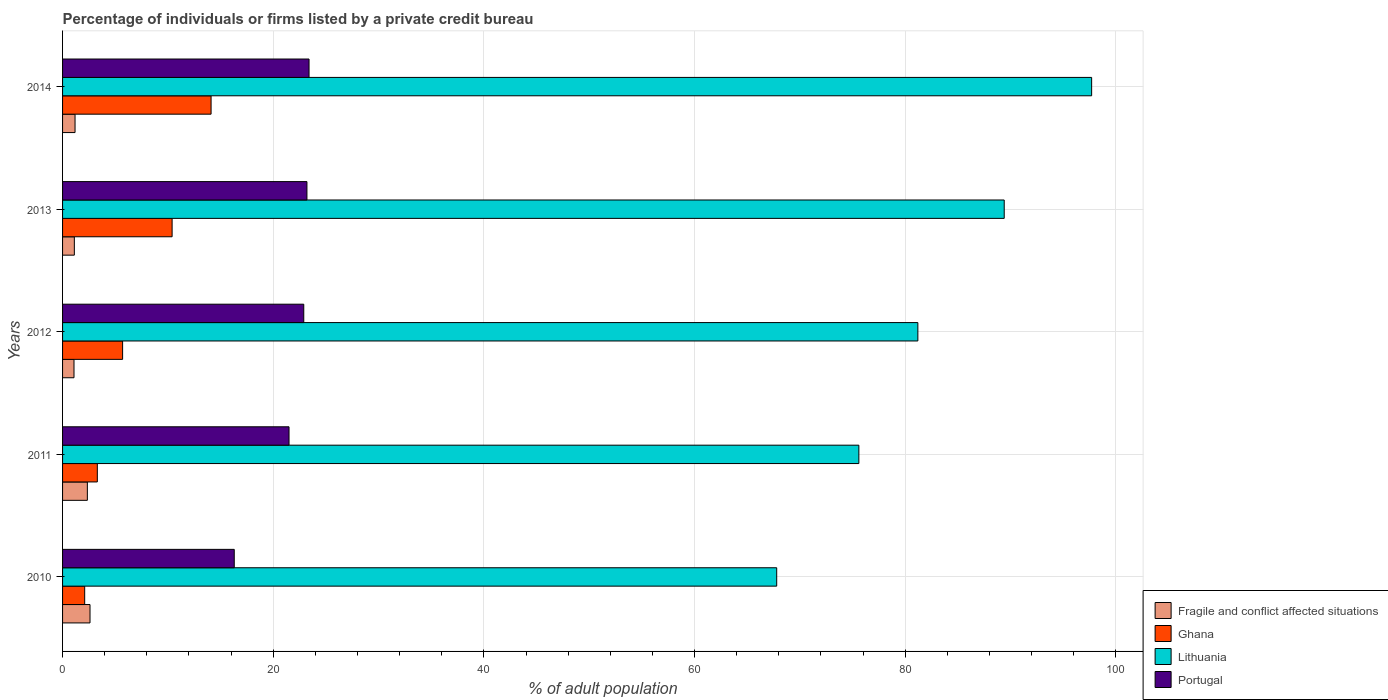How many different coloured bars are there?
Ensure brevity in your answer.  4. Are the number of bars on each tick of the Y-axis equal?
Offer a terse response. Yes. In how many cases, is the number of bars for a given year not equal to the number of legend labels?
Give a very brief answer. 0. What is the percentage of population listed by a private credit bureau in Portugal in 2013?
Make the answer very short. 23.2. Across all years, what is the maximum percentage of population listed by a private credit bureau in Fragile and conflict affected situations?
Offer a terse response. 2.61. Across all years, what is the minimum percentage of population listed by a private credit bureau in Portugal?
Your answer should be very brief. 16.3. What is the total percentage of population listed by a private credit bureau in Portugal in the graph?
Provide a short and direct response. 107.3. What is the difference between the percentage of population listed by a private credit bureau in Lithuania in 2012 and that in 2013?
Provide a short and direct response. -8.2. What is the difference between the percentage of population listed by a private credit bureau in Ghana in 2010 and the percentage of population listed by a private credit bureau in Portugal in 2011?
Your response must be concise. -19.4. What is the average percentage of population listed by a private credit bureau in Lithuania per year?
Your response must be concise. 82.34. In the year 2013, what is the difference between the percentage of population listed by a private credit bureau in Ghana and percentage of population listed by a private credit bureau in Fragile and conflict affected situations?
Provide a succinct answer. 9.28. In how many years, is the percentage of population listed by a private credit bureau in Lithuania greater than 24 %?
Offer a terse response. 5. What is the ratio of the percentage of population listed by a private credit bureau in Lithuania in 2011 to that in 2012?
Make the answer very short. 0.93. Is the percentage of population listed by a private credit bureau in Lithuania in 2013 less than that in 2014?
Provide a succinct answer. Yes. Is the difference between the percentage of population listed by a private credit bureau in Ghana in 2011 and 2014 greater than the difference between the percentage of population listed by a private credit bureau in Fragile and conflict affected situations in 2011 and 2014?
Provide a short and direct response. No. What is the difference between the highest and the second highest percentage of population listed by a private credit bureau in Portugal?
Offer a very short reply. 0.2. In how many years, is the percentage of population listed by a private credit bureau in Lithuania greater than the average percentage of population listed by a private credit bureau in Lithuania taken over all years?
Offer a terse response. 2. Is the sum of the percentage of population listed by a private credit bureau in Portugal in 2010 and 2013 greater than the maximum percentage of population listed by a private credit bureau in Ghana across all years?
Offer a terse response. Yes. Is it the case that in every year, the sum of the percentage of population listed by a private credit bureau in Ghana and percentage of population listed by a private credit bureau in Fragile and conflict affected situations is greater than the sum of percentage of population listed by a private credit bureau in Lithuania and percentage of population listed by a private credit bureau in Portugal?
Offer a very short reply. Yes. What does the 2nd bar from the top in 2011 represents?
Provide a short and direct response. Lithuania. What does the 4th bar from the bottom in 2014 represents?
Your response must be concise. Portugal. Is it the case that in every year, the sum of the percentage of population listed by a private credit bureau in Ghana and percentage of population listed by a private credit bureau in Lithuania is greater than the percentage of population listed by a private credit bureau in Fragile and conflict affected situations?
Provide a short and direct response. Yes. How many bars are there?
Make the answer very short. 20. Are all the bars in the graph horizontal?
Your response must be concise. Yes. Does the graph contain any zero values?
Ensure brevity in your answer.  No. Does the graph contain grids?
Offer a terse response. Yes. What is the title of the graph?
Your answer should be compact. Percentage of individuals or firms listed by a private credit bureau. What is the label or title of the X-axis?
Make the answer very short. % of adult population. What is the label or title of the Y-axis?
Keep it short and to the point. Years. What is the % of adult population in Fragile and conflict affected situations in 2010?
Ensure brevity in your answer.  2.61. What is the % of adult population in Ghana in 2010?
Offer a very short reply. 2.1. What is the % of adult population in Lithuania in 2010?
Provide a short and direct response. 67.8. What is the % of adult population of Portugal in 2010?
Your answer should be very brief. 16.3. What is the % of adult population in Fragile and conflict affected situations in 2011?
Offer a terse response. 2.35. What is the % of adult population of Lithuania in 2011?
Provide a short and direct response. 75.6. What is the % of adult population of Portugal in 2011?
Make the answer very short. 21.5. What is the % of adult population of Fragile and conflict affected situations in 2012?
Make the answer very short. 1.08. What is the % of adult population of Lithuania in 2012?
Your response must be concise. 81.2. What is the % of adult population in Portugal in 2012?
Make the answer very short. 22.9. What is the % of adult population in Fragile and conflict affected situations in 2013?
Offer a very short reply. 1.12. What is the % of adult population of Lithuania in 2013?
Offer a very short reply. 89.4. What is the % of adult population in Portugal in 2013?
Ensure brevity in your answer.  23.2. What is the % of adult population of Fragile and conflict affected situations in 2014?
Keep it short and to the point. 1.18. What is the % of adult population in Lithuania in 2014?
Keep it short and to the point. 97.7. What is the % of adult population of Portugal in 2014?
Ensure brevity in your answer.  23.4. Across all years, what is the maximum % of adult population in Fragile and conflict affected situations?
Provide a succinct answer. 2.61. Across all years, what is the maximum % of adult population in Lithuania?
Ensure brevity in your answer.  97.7. Across all years, what is the maximum % of adult population in Portugal?
Provide a succinct answer. 23.4. Across all years, what is the minimum % of adult population in Fragile and conflict affected situations?
Make the answer very short. 1.08. Across all years, what is the minimum % of adult population of Lithuania?
Offer a very short reply. 67.8. What is the total % of adult population in Fragile and conflict affected situations in the graph?
Your answer should be very brief. 8.35. What is the total % of adult population of Ghana in the graph?
Offer a very short reply. 35.6. What is the total % of adult population of Lithuania in the graph?
Offer a terse response. 411.7. What is the total % of adult population of Portugal in the graph?
Give a very brief answer. 107.3. What is the difference between the % of adult population of Fragile and conflict affected situations in 2010 and that in 2011?
Offer a terse response. 0.25. What is the difference between the % of adult population in Ghana in 2010 and that in 2011?
Offer a very short reply. -1.2. What is the difference between the % of adult population in Lithuania in 2010 and that in 2011?
Your answer should be compact. -7.8. What is the difference between the % of adult population in Fragile and conflict affected situations in 2010 and that in 2012?
Your answer should be compact. 1.52. What is the difference between the % of adult population in Lithuania in 2010 and that in 2012?
Give a very brief answer. -13.4. What is the difference between the % of adult population of Portugal in 2010 and that in 2012?
Give a very brief answer. -6.6. What is the difference between the % of adult population in Fragile and conflict affected situations in 2010 and that in 2013?
Your response must be concise. 1.49. What is the difference between the % of adult population in Ghana in 2010 and that in 2013?
Give a very brief answer. -8.3. What is the difference between the % of adult population in Lithuania in 2010 and that in 2013?
Your response must be concise. -21.6. What is the difference between the % of adult population of Portugal in 2010 and that in 2013?
Offer a terse response. -6.9. What is the difference between the % of adult population of Fragile and conflict affected situations in 2010 and that in 2014?
Make the answer very short. 1.42. What is the difference between the % of adult population in Lithuania in 2010 and that in 2014?
Keep it short and to the point. -29.9. What is the difference between the % of adult population in Fragile and conflict affected situations in 2011 and that in 2012?
Give a very brief answer. 1.27. What is the difference between the % of adult population in Ghana in 2011 and that in 2012?
Your answer should be compact. -2.4. What is the difference between the % of adult population in Lithuania in 2011 and that in 2012?
Your answer should be compact. -5.6. What is the difference between the % of adult population in Fragile and conflict affected situations in 2011 and that in 2013?
Provide a short and direct response. 1.24. What is the difference between the % of adult population of Ghana in 2011 and that in 2013?
Offer a terse response. -7.1. What is the difference between the % of adult population of Fragile and conflict affected situations in 2011 and that in 2014?
Make the answer very short. 1.17. What is the difference between the % of adult population in Lithuania in 2011 and that in 2014?
Make the answer very short. -22.1. What is the difference between the % of adult population in Fragile and conflict affected situations in 2012 and that in 2013?
Keep it short and to the point. -0.03. What is the difference between the % of adult population in Lithuania in 2012 and that in 2013?
Ensure brevity in your answer.  -8.2. What is the difference between the % of adult population of Portugal in 2012 and that in 2013?
Give a very brief answer. -0.3. What is the difference between the % of adult population in Fragile and conflict affected situations in 2012 and that in 2014?
Your response must be concise. -0.1. What is the difference between the % of adult population of Lithuania in 2012 and that in 2014?
Your response must be concise. -16.5. What is the difference between the % of adult population of Fragile and conflict affected situations in 2013 and that in 2014?
Provide a short and direct response. -0.07. What is the difference between the % of adult population in Portugal in 2013 and that in 2014?
Your answer should be compact. -0.2. What is the difference between the % of adult population in Fragile and conflict affected situations in 2010 and the % of adult population in Ghana in 2011?
Make the answer very short. -0.69. What is the difference between the % of adult population of Fragile and conflict affected situations in 2010 and the % of adult population of Lithuania in 2011?
Offer a terse response. -72.99. What is the difference between the % of adult population of Fragile and conflict affected situations in 2010 and the % of adult population of Portugal in 2011?
Your answer should be compact. -18.89. What is the difference between the % of adult population in Ghana in 2010 and the % of adult population in Lithuania in 2011?
Ensure brevity in your answer.  -73.5. What is the difference between the % of adult population of Ghana in 2010 and the % of adult population of Portugal in 2011?
Your response must be concise. -19.4. What is the difference between the % of adult population in Lithuania in 2010 and the % of adult population in Portugal in 2011?
Make the answer very short. 46.3. What is the difference between the % of adult population in Fragile and conflict affected situations in 2010 and the % of adult population in Ghana in 2012?
Give a very brief answer. -3.09. What is the difference between the % of adult population in Fragile and conflict affected situations in 2010 and the % of adult population in Lithuania in 2012?
Give a very brief answer. -78.59. What is the difference between the % of adult population of Fragile and conflict affected situations in 2010 and the % of adult population of Portugal in 2012?
Make the answer very short. -20.29. What is the difference between the % of adult population of Ghana in 2010 and the % of adult population of Lithuania in 2012?
Keep it short and to the point. -79.1. What is the difference between the % of adult population of Ghana in 2010 and the % of adult population of Portugal in 2012?
Your answer should be compact. -20.8. What is the difference between the % of adult population of Lithuania in 2010 and the % of adult population of Portugal in 2012?
Offer a terse response. 44.9. What is the difference between the % of adult population in Fragile and conflict affected situations in 2010 and the % of adult population in Ghana in 2013?
Ensure brevity in your answer.  -7.79. What is the difference between the % of adult population in Fragile and conflict affected situations in 2010 and the % of adult population in Lithuania in 2013?
Provide a short and direct response. -86.79. What is the difference between the % of adult population of Fragile and conflict affected situations in 2010 and the % of adult population of Portugal in 2013?
Provide a succinct answer. -20.59. What is the difference between the % of adult population of Ghana in 2010 and the % of adult population of Lithuania in 2013?
Give a very brief answer. -87.3. What is the difference between the % of adult population of Ghana in 2010 and the % of adult population of Portugal in 2013?
Give a very brief answer. -21.1. What is the difference between the % of adult population of Lithuania in 2010 and the % of adult population of Portugal in 2013?
Offer a terse response. 44.6. What is the difference between the % of adult population in Fragile and conflict affected situations in 2010 and the % of adult population in Ghana in 2014?
Give a very brief answer. -11.49. What is the difference between the % of adult population of Fragile and conflict affected situations in 2010 and the % of adult population of Lithuania in 2014?
Your answer should be compact. -95.09. What is the difference between the % of adult population of Fragile and conflict affected situations in 2010 and the % of adult population of Portugal in 2014?
Provide a short and direct response. -20.79. What is the difference between the % of adult population in Ghana in 2010 and the % of adult population in Lithuania in 2014?
Offer a very short reply. -95.6. What is the difference between the % of adult population of Ghana in 2010 and the % of adult population of Portugal in 2014?
Your answer should be very brief. -21.3. What is the difference between the % of adult population in Lithuania in 2010 and the % of adult population in Portugal in 2014?
Your answer should be compact. 44.4. What is the difference between the % of adult population of Fragile and conflict affected situations in 2011 and the % of adult population of Ghana in 2012?
Provide a short and direct response. -3.35. What is the difference between the % of adult population in Fragile and conflict affected situations in 2011 and the % of adult population in Lithuania in 2012?
Keep it short and to the point. -78.85. What is the difference between the % of adult population in Fragile and conflict affected situations in 2011 and the % of adult population in Portugal in 2012?
Your response must be concise. -20.55. What is the difference between the % of adult population in Ghana in 2011 and the % of adult population in Lithuania in 2012?
Offer a very short reply. -77.9. What is the difference between the % of adult population in Ghana in 2011 and the % of adult population in Portugal in 2012?
Make the answer very short. -19.6. What is the difference between the % of adult population of Lithuania in 2011 and the % of adult population of Portugal in 2012?
Keep it short and to the point. 52.7. What is the difference between the % of adult population of Fragile and conflict affected situations in 2011 and the % of adult population of Ghana in 2013?
Ensure brevity in your answer.  -8.05. What is the difference between the % of adult population in Fragile and conflict affected situations in 2011 and the % of adult population in Lithuania in 2013?
Provide a short and direct response. -87.05. What is the difference between the % of adult population of Fragile and conflict affected situations in 2011 and the % of adult population of Portugal in 2013?
Ensure brevity in your answer.  -20.85. What is the difference between the % of adult population in Ghana in 2011 and the % of adult population in Lithuania in 2013?
Offer a very short reply. -86.1. What is the difference between the % of adult population of Ghana in 2011 and the % of adult population of Portugal in 2013?
Ensure brevity in your answer.  -19.9. What is the difference between the % of adult population in Lithuania in 2011 and the % of adult population in Portugal in 2013?
Keep it short and to the point. 52.4. What is the difference between the % of adult population in Fragile and conflict affected situations in 2011 and the % of adult population in Ghana in 2014?
Provide a succinct answer. -11.75. What is the difference between the % of adult population of Fragile and conflict affected situations in 2011 and the % of adult population of Lithuania in 2014?
Your response must be concise. -95.35. What is the difference between the % of adult population of Fragile and conflict affected situations in 2011 and the % of adult population of Portugal in 2014?
Ensure brevity in your answer.  -21.05. What is the difference between the % of adult population in Ghana in 2011 and the % of adult population in Lithuania in 2014?
Your response must be concise. -94.4. What is the difference between the % of adult population in Ghana in 2011 and the % of adult population in Portugal in 2014?
Offer a terse response. -20.1. What is the difference between the % of adult population of Lithuania in 2011 and the % of adult population of Portugal in 2014?
Provide a succinct answer. 52.2. What is the difference between the % of adult population of Fragile and conflict affected situations in 2012 and the % of adult population of Ghana in 2013?
Offer a very short reply. -9.32. What is the difference between the % of adult population of Fragile and conflict affected situations in 2012 and the % of adult population of Lithuania in 2013?
Provide a short and direct response. -88.32. What is the difference between the % of adult population of Fragile and conflict affected situations in 2012 and the % of adult population of Portugal in 2013?
Your response must be concise. -22.12. What is the difference between the % of adult population of Ghana in 2012 and the % of adult population of Lithuania in 2013?
Ensure brevity in your answer.  -83.7. What is the difference between the % of adult population in Ghana in 2012 and the % of adult population in Portugal in 2013?
Offer a very short reply. -17.5. What is the difference between the % of adult population in Fragile and conflict affected situations in 2012 and the % of adult population in Ghana in 2014?
Ensure brevity in your answer.  -13.02. What is the difference between the % of adult population of Fragile and conflict affected situations in 2012 and the % of adult population of Lithuania in 2014?
Keep it short and to the point. -96.62. What is the difference between the % of adult population in Fragile and conflict affected situations in 2012 and the % of adult population in Portugal in 2014?
Your answer should be compact. -22.32. What is the difference between the % of adult population in Ghana in 2012 and the % of adult population in Lithuania in 2014?
Offer a terse response. -92. What is the difference between the % of adult population in Ghana in 2012 and the % of adult population in Portugal in 2014?
Your answer should be very brief. -17.7. What is the difference between the % of adult population in Lithuania in 2012 and the % of adult population in Portugal in 2014?
Ensure brevity in your answer.  57.8. What is the difference between the % of adult population of Fragile and conflict affected situations in 2013 and the % of adult population of Ghana in 2014?
Your response must be concise. -12.98. What is the difference between the % of adult population in Fragile and conflict affected situations in 2013 and the % of adult population in Lithuania in 2014?
Your answer should be compact. -96.58. What is the difference between the % of adult population of Fragile and conflict affected situations in 2013 and the % of adult population of Portugal in 2014?
Keep it short and to the point. -22.28. What is the difference between the % of adult population of Ghana in 2013 and the % of adult population of Lithuania in 2014?
Provide a succinct answer. -87.3. What is the average % of adult population of Fragile and conflict affected situations per year?
Provide a succinct answer. 1.67. What is the average % of adult population in Ghana per year?
Give a very brief answer. 7.12. What is the average % of adult population of Lithuania per year?
Provide a succinct answer. 82.34. What is the average % of adult population of Portugal per year?
Make the answer very short. 21.46. In the year 2010, what is the difference between the % of adult population in Fragile and conflict affected situations and % of adult population in Ghana?
Give a very brief answer. 0.51. In the year 2010, what is the difference between the % of adult population in Fragile and conflict affected situations and % of adult population in Lithuania?
Provide a succinct answer. -65.19. In the year 2010, what is the difference between the % of adult population of Fragile and conflict affected situations and % of adult population of Portugal?
Ensure brevity in your answer.  -13.69. In the year 2010, what is the difference between the % of adult population of Ghana and % of adult population of Lithuania?
Provide a short and direct response. -65.7. In the year 2010, what is the difference between the % of adult population of Lithuania and % of adult population of Portugal?
Offer a very short reply. 51.5. In the year 2011, what is the difference between the % of adult population of Fragile and conflict affected situations and % of adult population of Ghana?
Give a very brief answer. -0.95. In the year 2011, what is the difference between the % of adult population of Fragile and conflict affected situations and % of adult population of Lithuania?
Your answer should be very brief. -73.25. In the year 2011, what is the difference between the % of adult population of Fragile and conflict affected situations and % of adult population of Portugal?
Ensure brevity in your answer.  -19.15. In the year 2011, what is the difference between the % of adult population of Ghana and % of adult population of Lithuania?
Your response must be concise. -72.3. In the year 2011, what is the difference between the % of adult population of Ghana and % of adult population of Portugal?
Make the answer very short. -18.2. In the year 2011, what is the difference between the % of adult population of Lithuania and % of adult population of Portugal?
Provide a succinct answer. 54.1. In the year 2012, what is the difference between the % of adult population in Fragile and conflict affected situations and % of adult population in Ghana?
Ensure brevity in your answer.  -4.62. In the year 2012, what is the difference between the % of adult population in Fragile and conflict affected situations and % of adult population in Lithuania?
Your response must be concise. -80.12. In the year 2012, what is the difference between the % of adult population in Fragile and conflict affected situations and % of adult population in Portugal?
Make the answer very short. -21.82. In the year 2012, what is the difference between the % of adult population of Ghana and % of adult population of Lithuania?
Provide a short and direct response. -75.5. In the year 2012, what is the difference between the % of adult population in Ghana and % of adult population in Portugal?
Keep it short and to the point. -17.2. In the year 2012, what is the difference between the % of adult population in Lithuania and % of adult population in Portugal?
Offer a terse response. 58.3. In the year 2013, what is the difference between the % of adult population in Fragile and conflict affected situations and % of adult population in Ghana?
Offer a terse response. -9.28. In the year 2013, what is the difference between the % of adult population of Fragile and conflict affected situations and % of adult population of Lithuania?
Provide a succinct answer. -88.28. In the year 2013, what is the difference between the % of adult population of Fragile and conflict affected situations and % of adult population of Portugal?
Offer a terse response. -22.08. In the year 2013, what is the difference between the % of adult population of Ghana and % of adult population of Lithuania?
Offer a terse response. -79. In the year 2013, what is the difference between the % of adult population in Lithuania and % of adult population in Portugal?
Your answer should be compact. 66.2. In the year 2014, what is the difference between the % of adult population in Fragile and conflict affected situations and % of adult population in Ghana?
Offer a very short reply. -12.92. In the year 2014, what is the difference between the % of adult population in Fragile and conflict affected situations and % of adult population in Lithuania?
Provide a succinct answer. -96.52. In the year 2014, what is the difference between the % of adult population in Fragile and conflict affected situations and % of adult population in Portugal?
Your answer should be very brief. -22.22. In the year 2014, what is the difference between the % of adult population of Ghana and % of adult population of Lithuania?
Offer a terse response. -83.6. In the year 2014, what is the difference between the % of adult population in Ghana and % of adult population in Portugal?
Your answer should be very brief. -9.3. In the year 2014, what is the difference between the % of adult population of Lithuania and % of adult population of Portugal?
Your answer should be compact. 74.3. What is the ratio of the % of adult population of Fragile and conflict affected situations in 2010 to that in 2011?
Give a very brief answer. 1.11. What is the ratio of the % of adult population in Ghana in 2010 to that in 2011?
Offer a very short reply. 0.64. What is the ratio of the % of adult population in Lithuania in 2010 to that in 2011?
Ensure brevity in your answer.  0.9. What is the ratio of the % of adult population of Portugal in 2010 to that in 2011?
Give a very brief answer. 0.76. What is the ratio of the % of adult population in Fragile and conflict affected situations in 2010 to that in 2012?
Offer a terse response. 2.4. What is the ratio of the % of adult population in Ghana in 2010 to that in 2012?
Your answer should be very brief. 0.37. What is the ratio of the % of adult population of Lithuania in 2010 to that in 2012?
Give a very brief answer. 0.83. What is the ratio of the % of adult population in Portugal in 2010 to that in 2012?
Make the answer very short. 0.71. What is the ratio of the % of adult population of Fragile and conflict affected situations in 2010 to that in 2013?
Make the answer very short. 2.33. What is the ratio of the % of adult population in Ghana in 2010 to that in 2013?
Your answer should be very brief. 0.2. What is the ratio of the % of adult population in Lithuania in 2010 to that in 2013?
Your response must be concise. 0.76. What is the ratio of the % of adult population in Portugal in 2010 to that in 2013?
Your answer should be very brief. 0.7. What is the ratio of the % of adult population of Ghana in 2010 to that in 2014?
Offer a terse response. 0.15. What is the ratio of the % of adult population of Lithuania in 2010 to that in 2014?
Keep it short and to the point. 0.69. What is the ratio of the % of adult population in Portugal in 2010 to that in 2014?
Provide a succinct answer. 0.7. What is the ratio of the % of adult population of Fragile and conflict affected situations in 2011 to that in 2012?
Ensure brevity in your answer.  2.17. What is the ratio of the % of adult population of Ghana in 2011 to that in 2012?
Offer a very short reply. 0.58. What is the ratio of the % of adult population in Portugal in 2011 to that in 2012?
Your response must be concise. 0.94. What is the ratio of the % of adult population of Fragile and conflict affected situations in 2011 to that in 2013?
Your answer should be compact. 2.1. What is the ratio of the % of adult population in Ghana in 2011 to that in 2013?
Your answer should be compact. 0.32. What is the ratio of the % of adult population of Lithuania in 2011 to that in 2013?
Ensure brevity in your answer.  0.85. What is the ratio of the % of adult population of Portugal in 2011 to that in 2013?
Offer a very short reply. 0.93. What is the ratio of the % of adult population of Fragile and conflict affected situations in 2011 to that in 2014?
Ensure brevity in your answer.  1.99. What is the ratio of the % of adult population in Ghana in 2011 to that in 2014?
Keep it short and to the point. 0.23. What is the ratio of the % of adult population of Lithuania in 2011 to that in 2014?
Offer a terse response. 0.77. What is the ratio of the % of adult population of Portugal in 2011 to that in 2014?
Your answer should be very brief. 0.92. What is the ratio of the % of adult population in Fragile and conflict affected situations in 2012 to that in 2013?
Your answer should be compact. 0.97. What is the ratio of the % of adult population of Ghana in 2012 to that in 2013?
Offer a terse response. 0.55. What is the ratio of the % of adult population of Lithuania in 2012 to that in 2013?
Make the answer very short. 0.91. What is the ratio of the % of adult population in Portugal in 2012 to that in 2013?
Give a very brief answer. 0.99. What is the ratio of the % of adult population in Fragile and conflict affected situations in 2012 to that in 2014?
Offer a terse response. 0.92. What is the ratio of the % of adult population of Ghana in 2012 to that in 2014?
Provide a succinct answer. 0.4. What is the ratio of the % of adult population of Lithuania in 2012 to that in 2014?
Your response must be concise. 0.83. What is the ratio of the % of adult population of Portugal in 2012 to that in 2014?
Make the answer very short. 0.98. What is the ratio of the % of adult population in Fragile and conflict affected situations in 2013 to that in 2014?
Your answer should be compact. 0.94. What is the ratio of the % of adult population in Ghana in 2013 to that in 2014?
Ensure brevity in your answer.  0.74. What is the ratio of the % of adult population of Lithuania in 2013 to that in 2014?
Your response must be concise. 0.92. What is the difference between the highest and the second highest % of adult population in Fragile and conflict affected situations?
Offer a terse response. 0.25. What is the difference between the highest and the second highest % of adult population in Ghana?
Give a very brief answer. 3.7. What is the difference between the highest and the lowest % of adult population in Fragile and conflict affected situations?
Your answer should be compact. 1.52. What is the difference between the highest and the lowest % of adult population of Ghana?
Provide a succinct answer. 12. What is the difference between the highest and the lowest % of adult population in Lithuania?
Provide a succinct answer. 29.9. What is the difference between the highest and the lowest % of adult population of Portugal?
Your answer should be very brief. 7.1. 